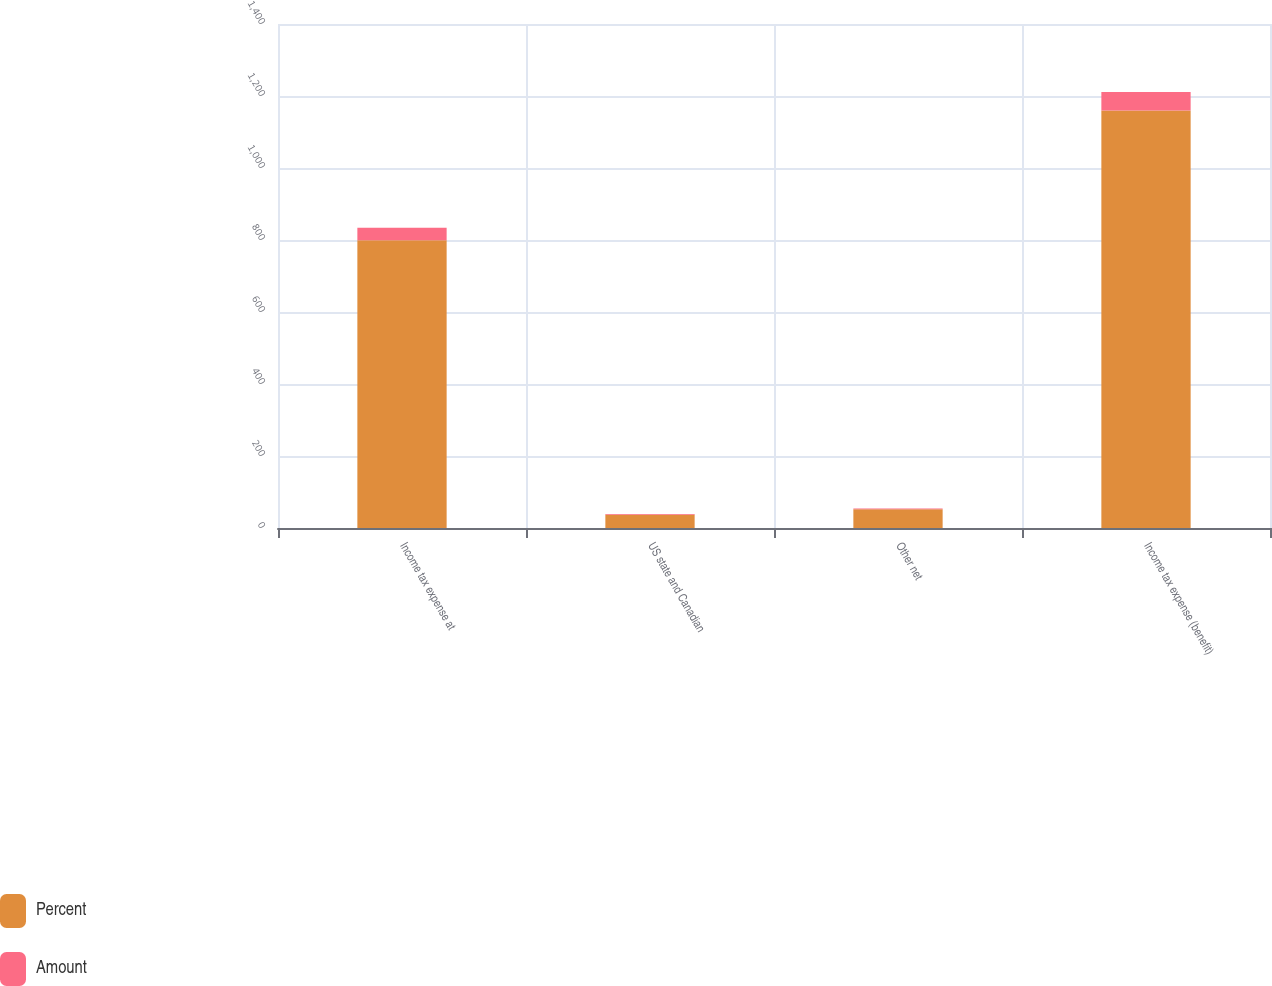Convert chart. <chart><loc_0><loc_0><loc_500><loc_500><stacked_bar_chart><ecel><fcel>Income tax expense at<fcel>US state and Canadian<fcel>Other net<fcel>Income tax expense (benefit)<nl><fcel>Percent<fcel>799<fcel>37<fcel>52<fcel>1160<nl><fcel>Amount<fcel>35<fcel>1.6<fcel>2.3<fcel>50.9<nl></chart> 